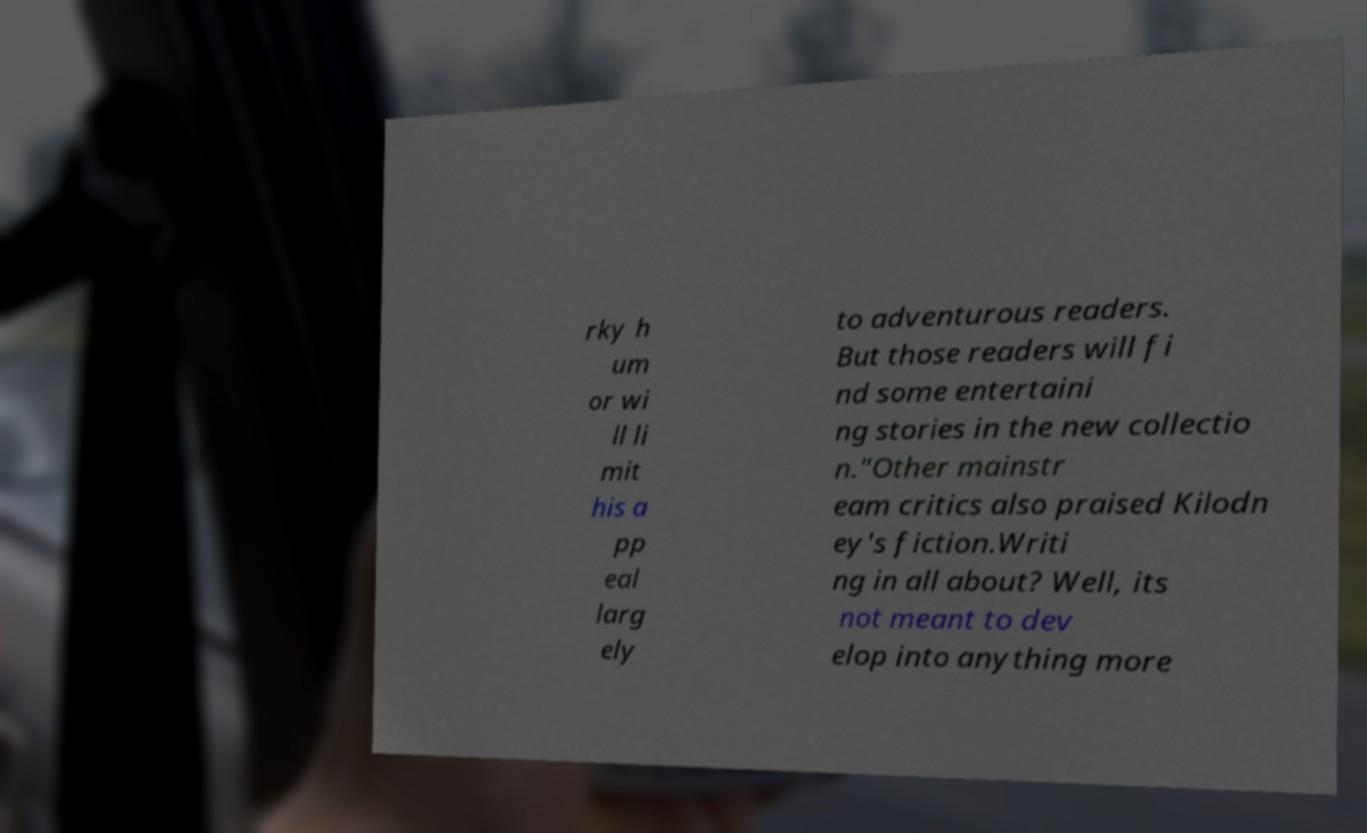Please read and relay the text visible in this image. What does it say? rky h um or wi ll li mit his a pp eal larg ely to adventurous readers. But those readers will fi nd some entertaini ng stories in the new collectio n."Other mainstr eam critics also praised Kilodn ey's fiction.Writi ng in all about? Well, its not meant to dev elop into anything more 